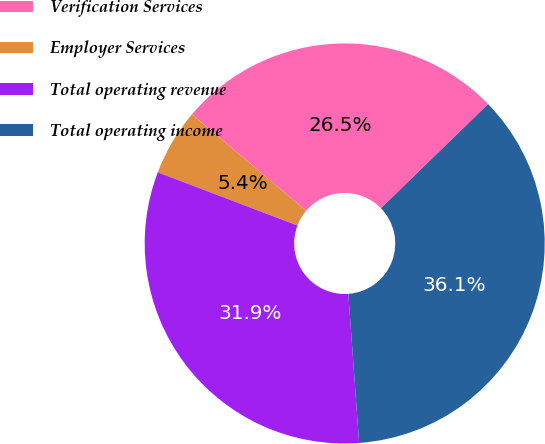<chart> <loc_0><loc_0><loc_500><loc_500><pie_chart><fcel>Verification Services<fcel>Employer Services<fcel>Total operating revenue<fcel>Total operating income<nl><fcel>26.55%<fcel>5.39%<fcel>31.94%<fcel>36.13%<nl></chart> 